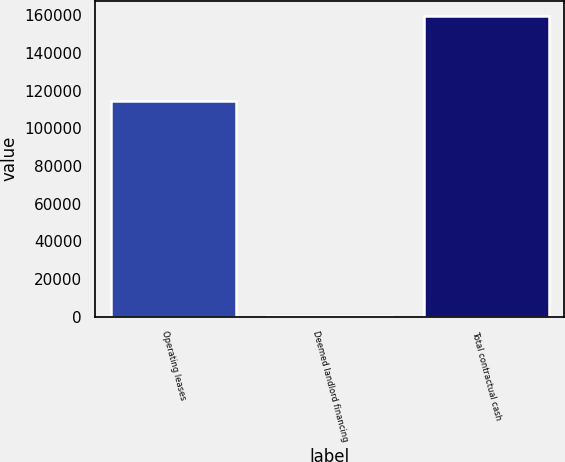Convert chart. <chart><loc_0><loc_0><loc_500><loc_500><bar_chart><fcel>Operating leases<fcel>Deemed landlord financing<fcel>Total contractual cash<nl><fcel>114754<fcel>391<fcel>159743<nl></chart> 